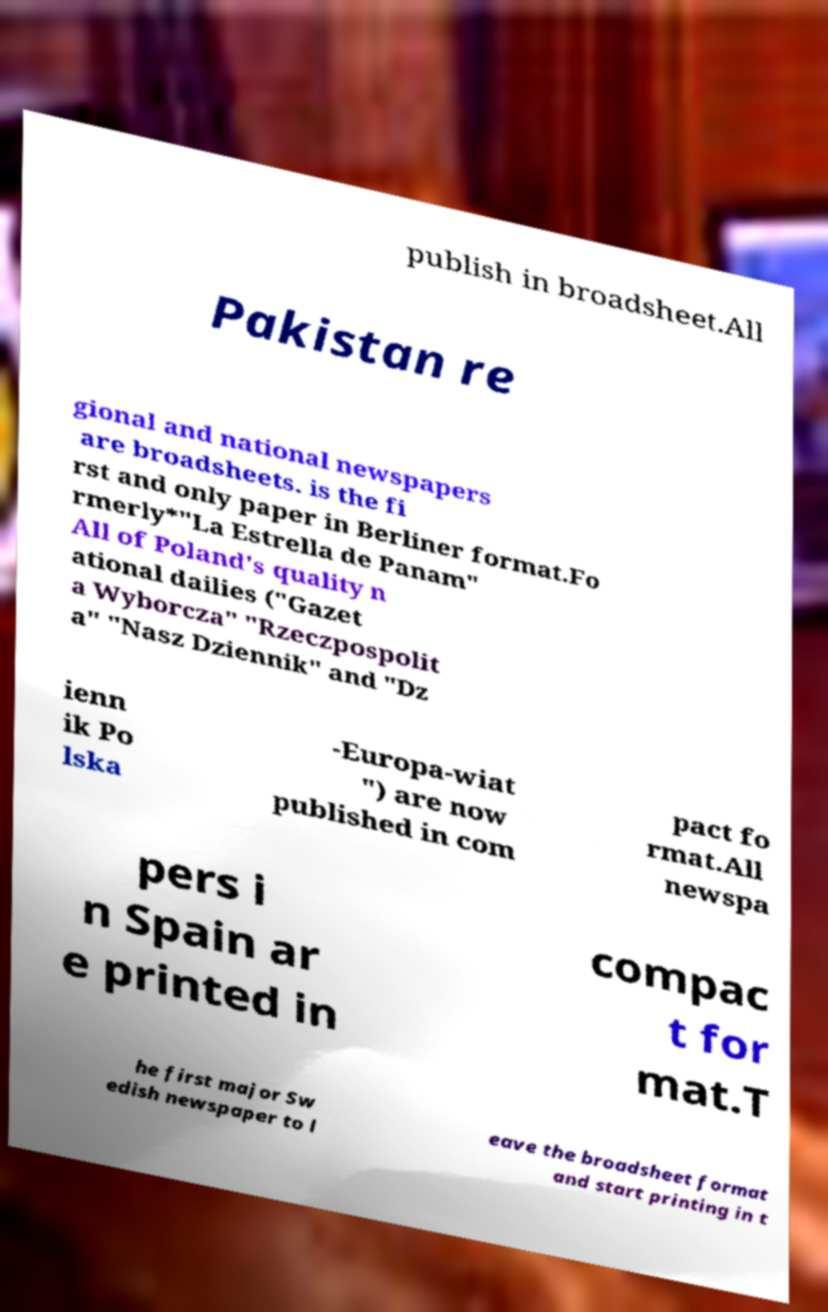There's text embedded in this image that I need extracted. Can you transcribe it verbatim? publish in broadsheet.All Pakistan re gional and national newspapers are broadsheets. is the fi rst and only paper in Berliner format.Fo rmerly*"La Estrella de Panam" All of Poland's quality n ational dailies ("Gazet a Wyborcza" "Rzeczpospolit a" "Nasz Dziennik" and "Dz ienn ik Po lska -Europa-wiat ") are now published in com pact fo rmat.All newspa pers i n Spain ar e printed in compac t for mat.T he first major Sw edish newspaper to l eave the broadsheet format and start printing in t 